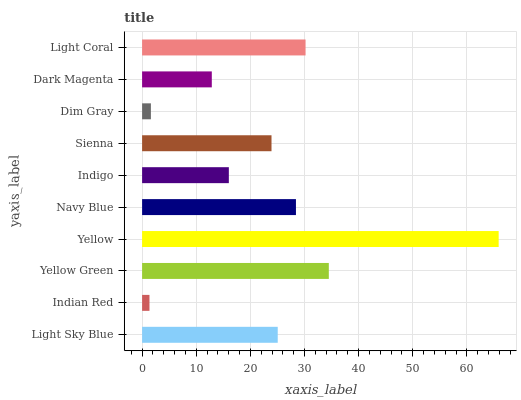Is Indian Red the minimum?
Answer yes or no. Yes. Is Yellow the maximum?
Answer yes or no. Yes. Is Yellow Green the minimum?
Answer yes or no. No. Is Yellow Green the maximum?
Answer yes or no. No. Is Yellow Green greater than Indian Red?
Answer yes or no. Yes. Is Indian Red less than Yellow Green?
Answer yes or no. Yes. Is Indian Red greater than Yellow Green?
Answer yes or no. No. Is Yellow Green less than Indian Red?
Answer yes or no. No. Is Light Sky Blue the high median?
Answer yes or no. Yes. Is Sienna the low median?
Answer yes or no. Yes. Is Sienna the high median?
Answer yes or no. No. Is Yellow Green the low median?
Answer yes or no. No. 